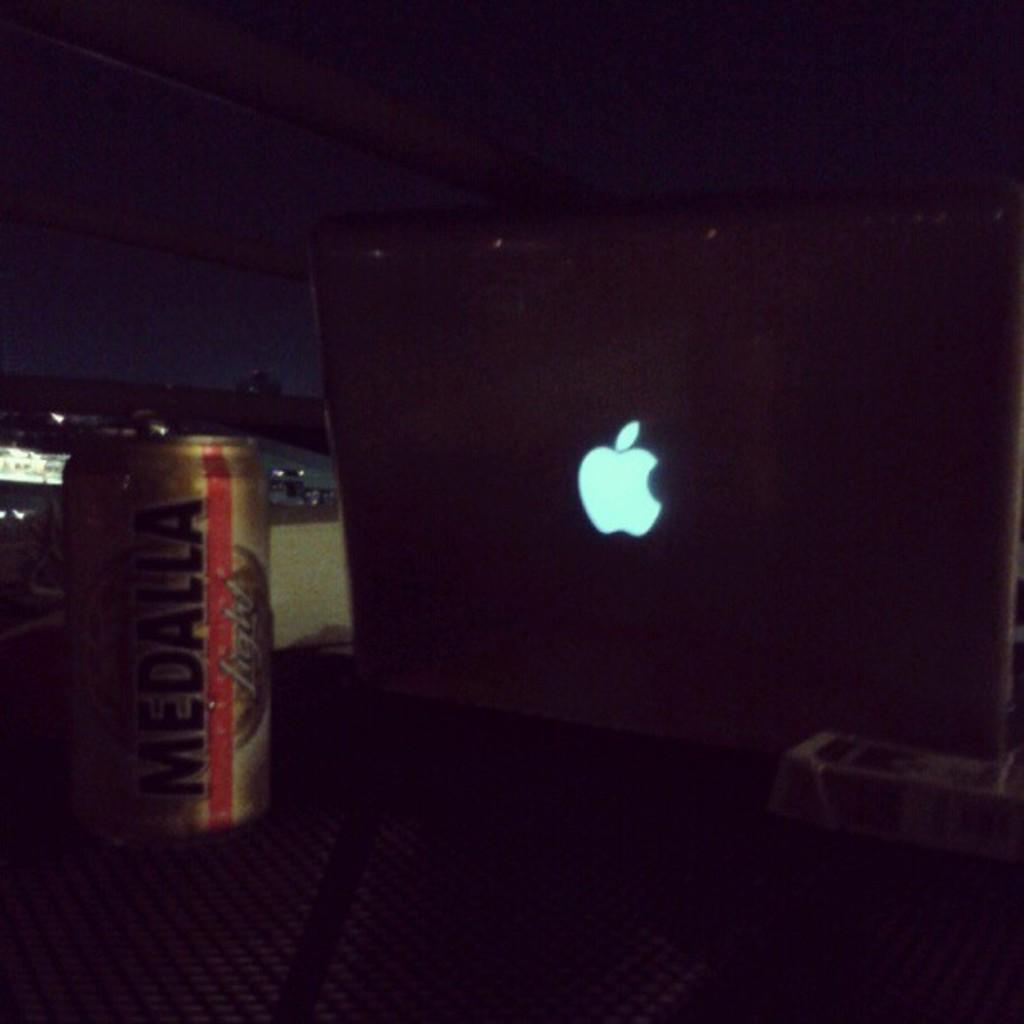<image>
Present a compact description of the photo's key features. an apple logo next to a beer can with the letter A on it 